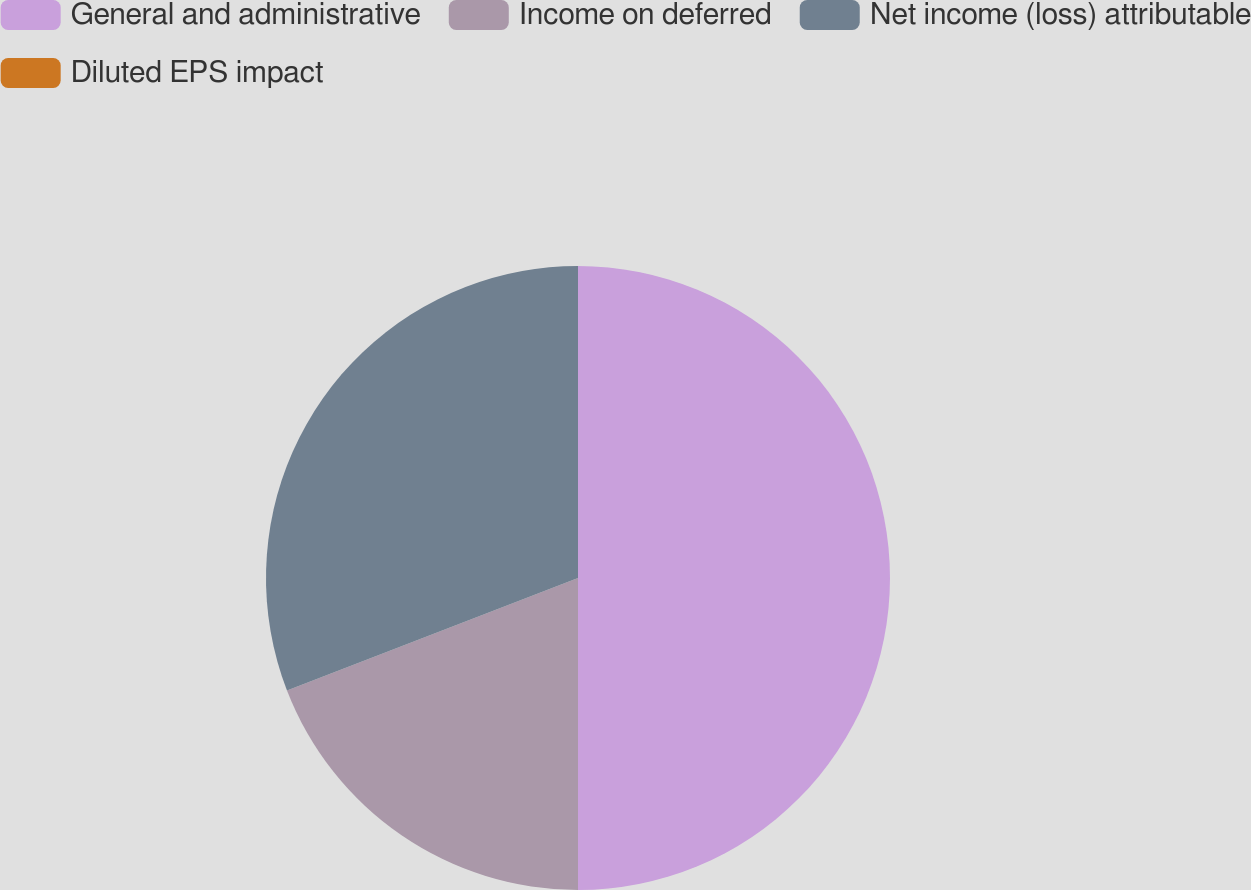<chart> <loc_0><loc_0><loc_500><loc_500><pie_chart><fcel>General and administrative<fcel>Income on deferred<fcel>Net income (loss) attributable<fcel>Diluted EPS impact<nl><fcel>50.0%<fcel>19.13%<fcel>30.87%<fcel>0.0%<nl></chart> 